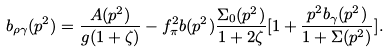Convert formula to latex. <formula><loc_0><loc_0><loc_500><loc_500>b _ { \rho \gamma } ( p ^ { 2 } ) = \frac { A ( p ^ { 2 } ) } { g ( 1 + \zeta ) } - f _ { \pi } ^ { 2 } b ( p ^ { 2 } ) \frac { \Sigma _ { 0 } ( p ^ { 2 } ) } { 1 + 2 \zeta } [ 1 + \frac { p ^ { 2 } b _ { \gamma } ( p ^ { 2 } ) } { 1 + \Sigma ( p ^ { 2 } ) } ] .</formula> 